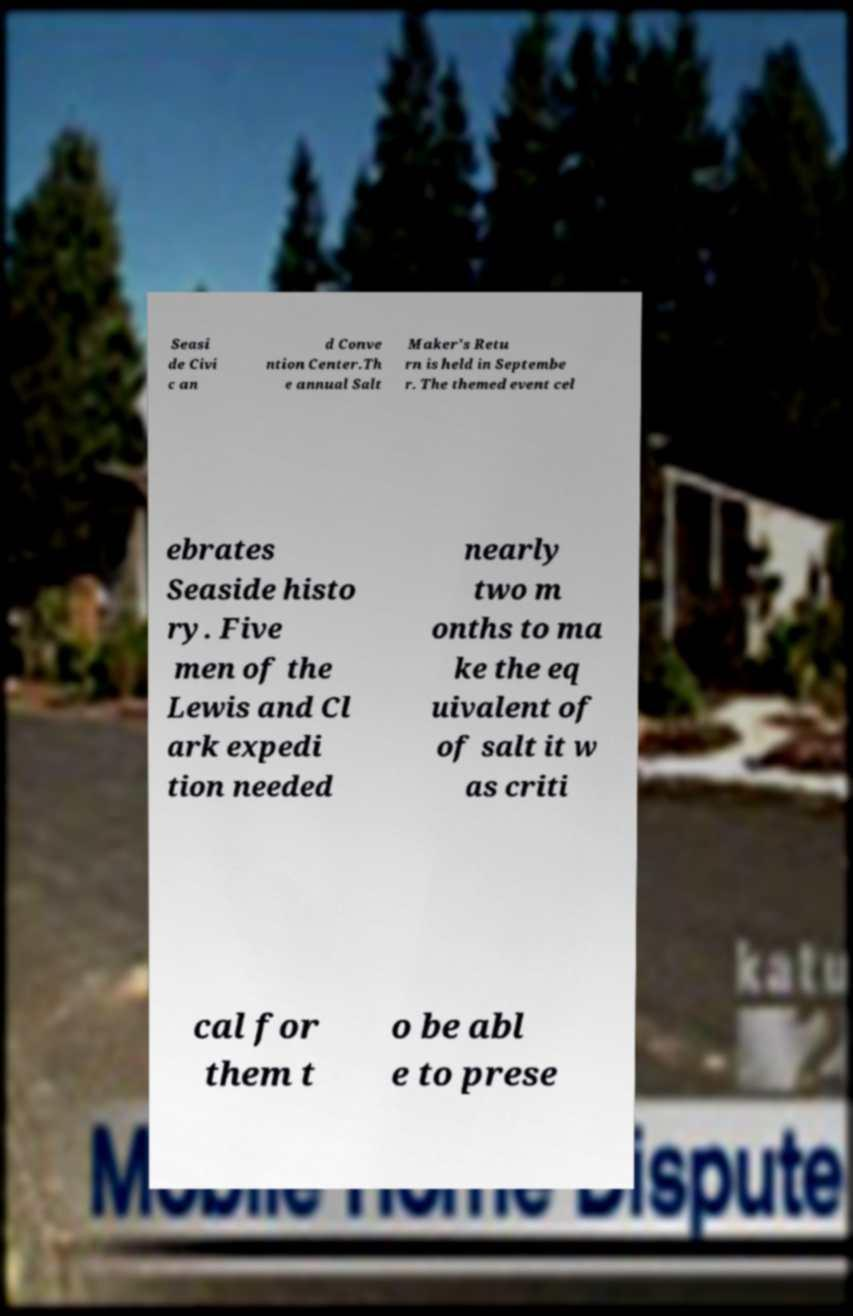For documentation purposes, I need the text within this image transcribed. Could you provide that? Seasi de Civi c an d Conve ntion Center.Th e annual Salt Maker's Retu rn is held in Septembe r. The themed event cel ebrates Seaside histo ry. Five men of the Lewis and Cl ark expedi tion needed nearly two m onths to ma ke the eq uivalent of of salt it w as criti cal for them t o be abl e to prese 